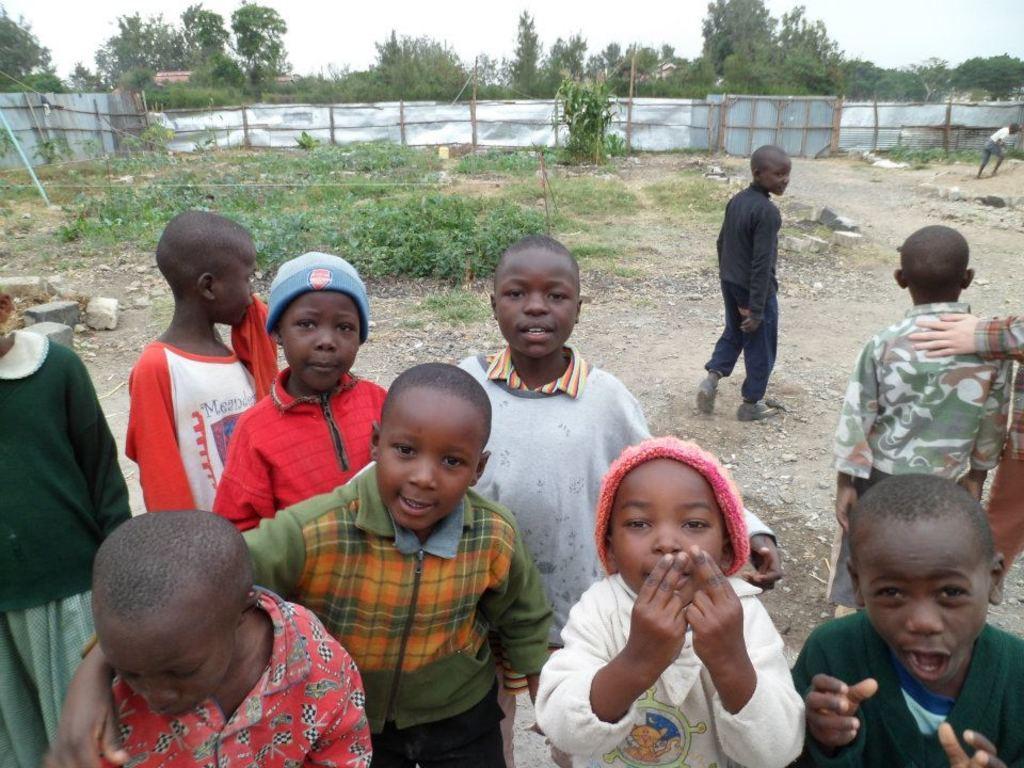In one or two sentences, can you explain what this image depicts? In this image in the front there are group of kids standing. On the right side there is a kid walking wearing a black colour dress. In the background there is grass on the ground and there is a fence and there are trees and the sky is cloudy. 